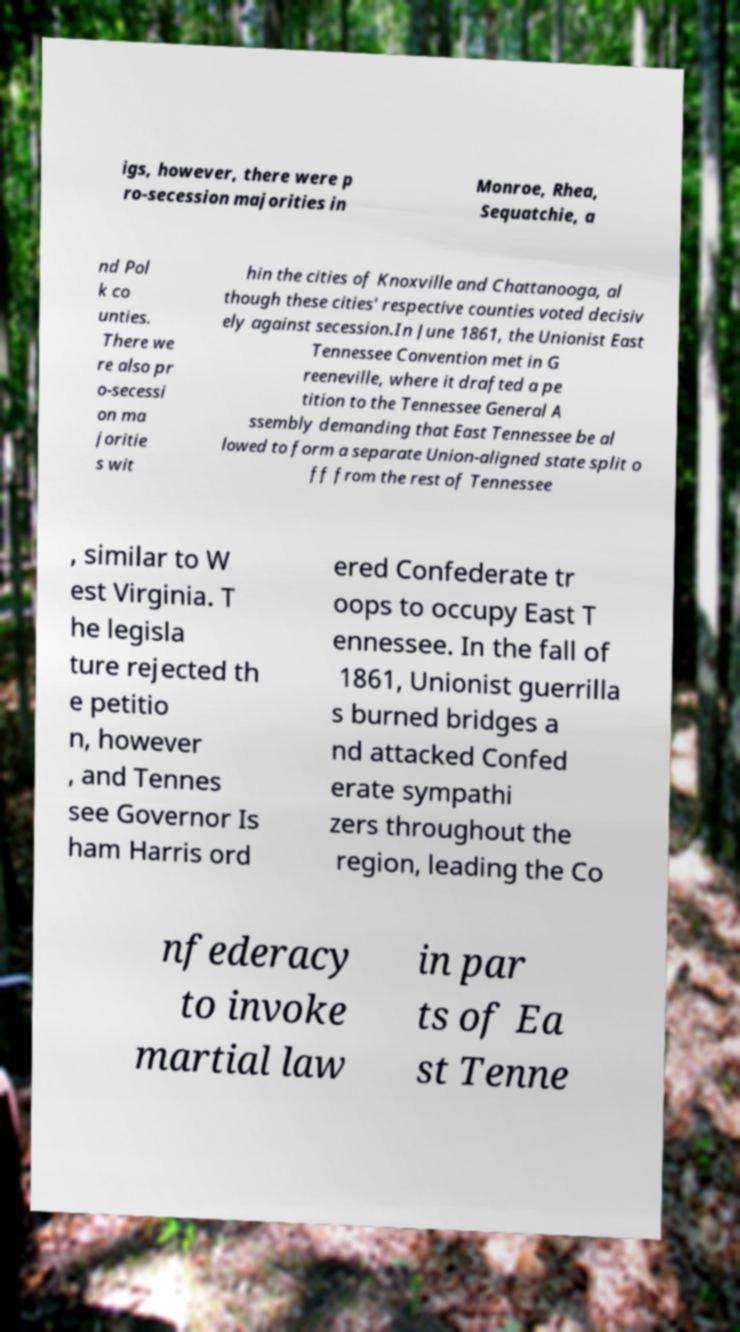Can you accurately transcribe the text from the provided image for me? igs, however, there were p ro-secession majorities in Monroe, Rhea, Sequatchie, a nd Pol k co unties. There we re also pr o-secessi on ma joritie s wit hin the cities of Knoxville and Chattanooga, al though these cities' respective counties voted decisiv ely against secession.In June 1861, the Unionist East Tennessee Convention met in G reeneville, where it drafted a pe tition to the Tennessee General A ssembly demanding that East Tennessee be al lowed to form a separate Union-aligned state split o ff from the rest of Tennessee , similar to W est Virginia. T he legisla ture rejected th e petitio n, however , and Tennes see Governor Is ham Harris ord ered Confederate tr oops to occupy East T ennessee. In the fall of 1861, Unionist guerrilla s burned bridges a nd attacked Confed erate sympathi zers throughout the region, leading the Co nfederacy to invoke martial law in par ts of Ea st Tenne 